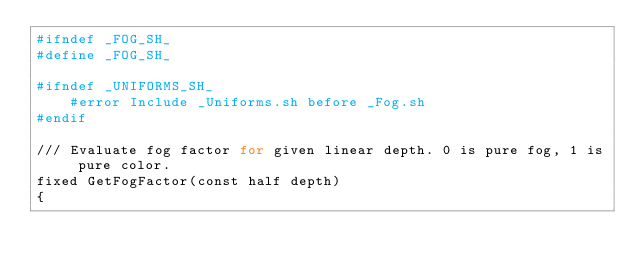Convert code to text. <code><loc_0><loc_0><loc_500><loc_500><_Bash_>#ifndef _FOG_SH_
#define _FOG_SH_

#ifndef _UNIFORMS_SH_
    #error Include _Uniforms.sh before _Fog.sh
#endif

/// Evaluate fog factor for given linear depth. 0 is pure fog, 1 is pure color.
fixed GetFogFactor(const half depth)
{</code> 